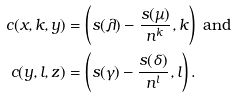<formula> <loc_0><loc_0><loc_500><loc_500>c ( x , k , y ) & = \left ( s ( \lambda ) - \frac { s ( \mu ) } { n ^ { k } } , k \right ) \text { and} \\ c ( y , l , z ) & = \left ( s ( \gamma ) - \frac { s ( \delta ) } { n ^ { l } } , l \right ) .</formula> 